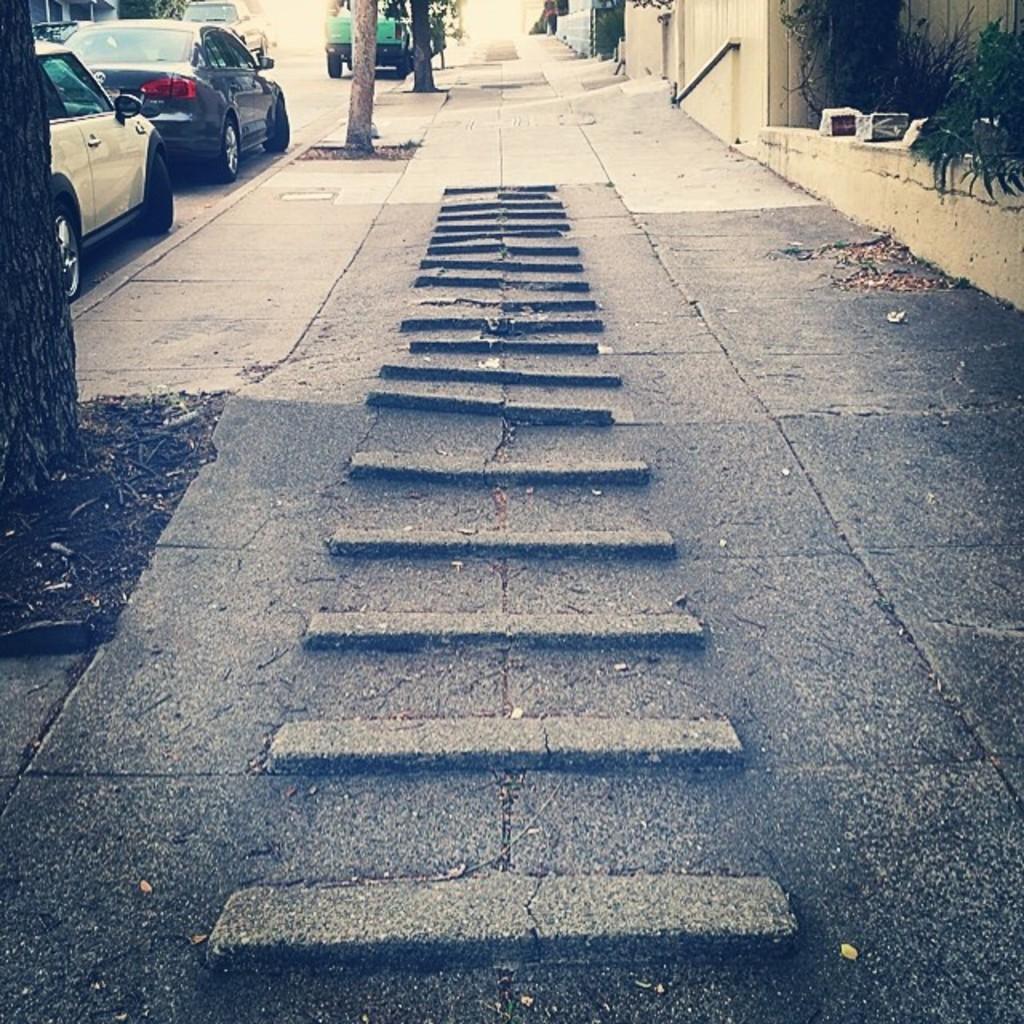Could you give a brief overview of what you see in this image? In the picture I can see the walkway. I can see the trunk of trees on the side of the road. There are cars on the road on the top left side of the picture. 